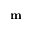Convert formula to latex. <formula><loc_0><loc_0><loc_500><loc_500>m</formula> 